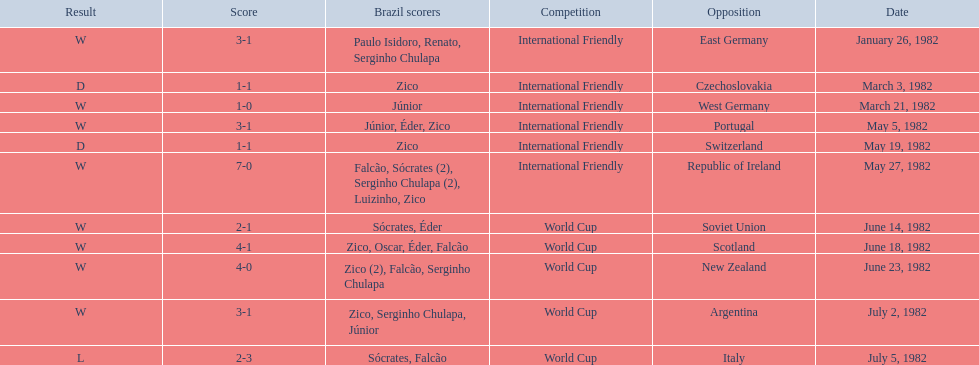What were the scores of each of game in the 1982 brazilian football games? 3-1, 1-1, 1-0, 3-1, 1-1, 7-0, 2-1, 4-1, 4-0, 3-1, 2-3. Of those, which were scores from games against portugal and the soviet union? 3-1, 2-1. And between those two games, against which country did brazil score more goals? Portugal. 